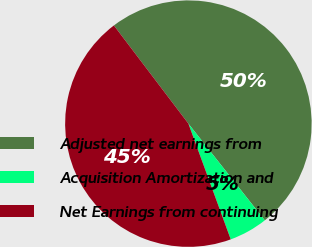<chart> <loc_0><loc_0><loc_500><loc_500><pie_chart><fcel>Adjusted net earnings from<fcel>Acquisition Amortization and<fcel>Net Earnings from continuing<nl><fcel>49.69%<fcel>5.06%<fcel>45.25%<nl></chart> 